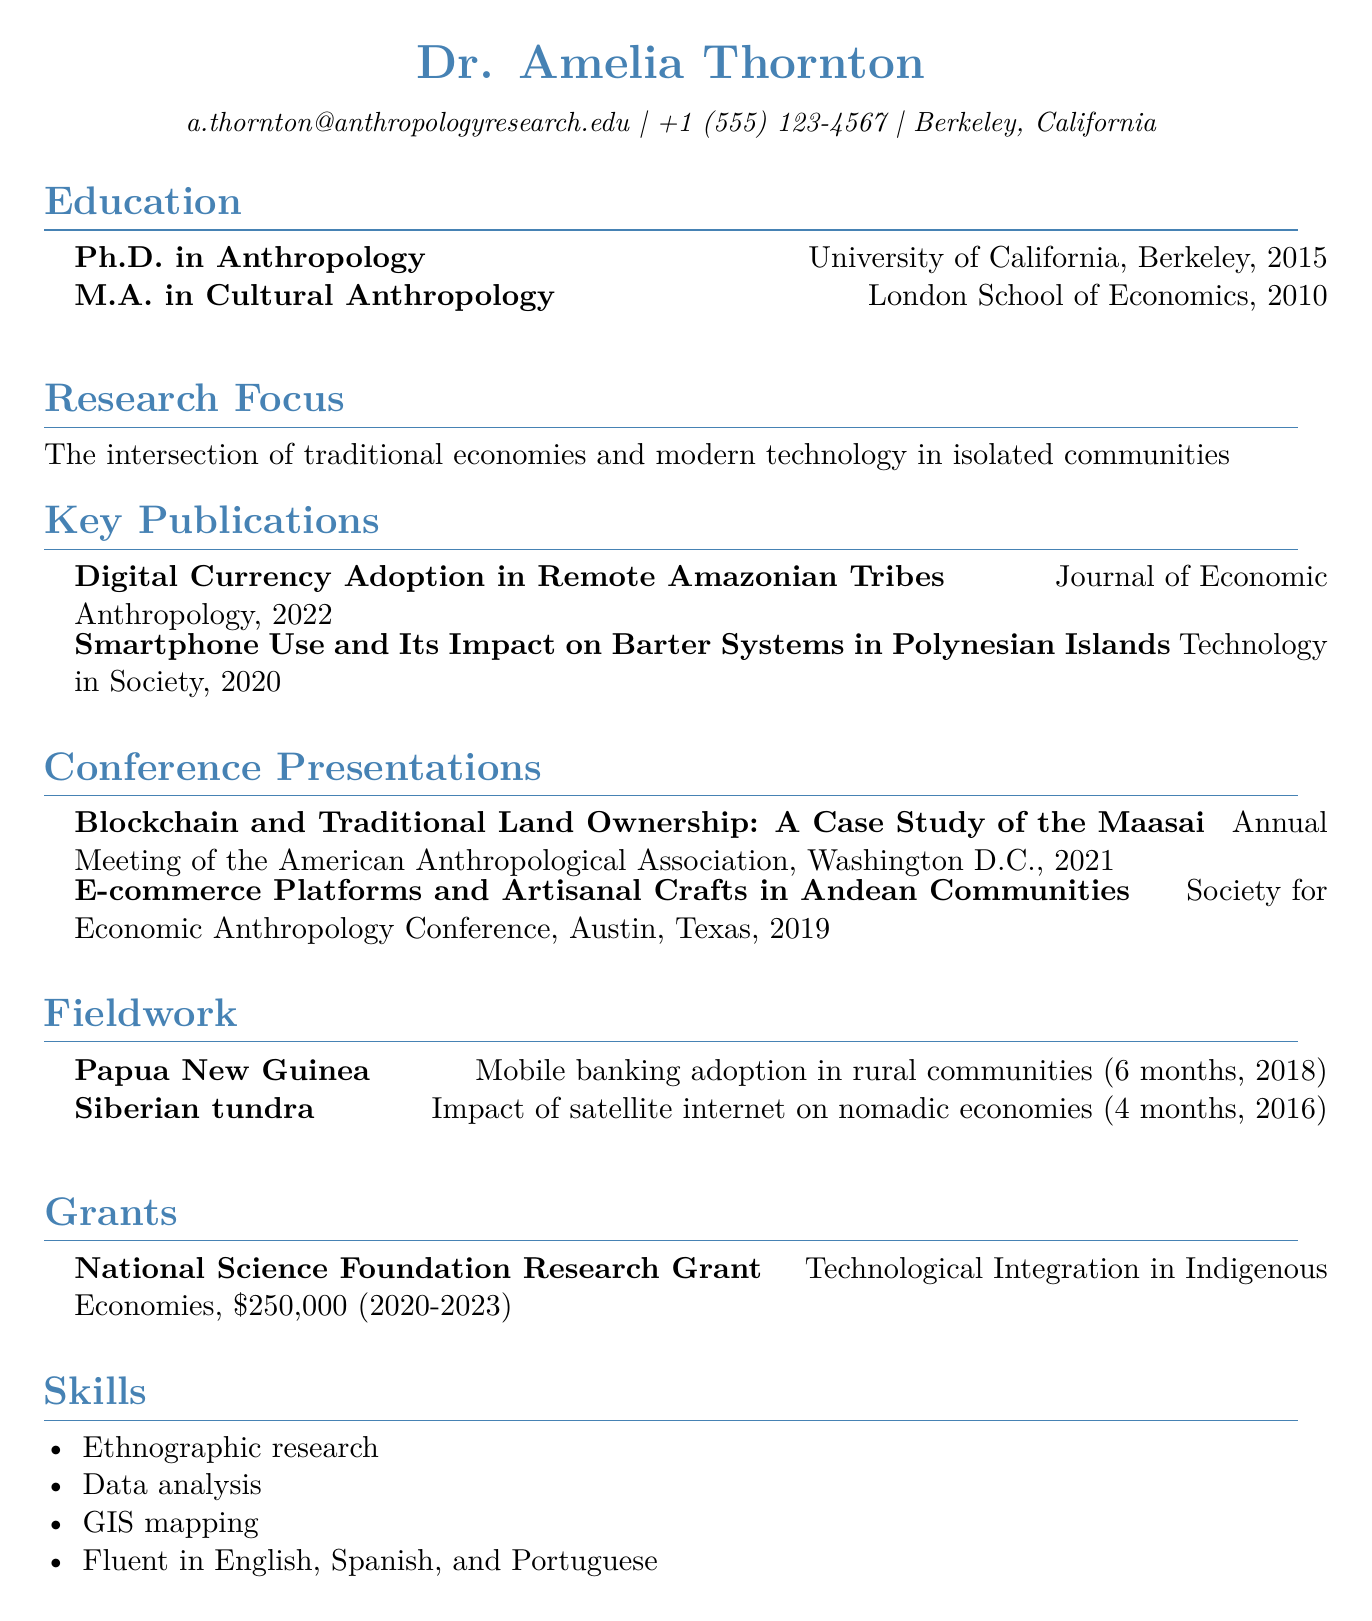What is the author's name? The author's name is prominently displayed at the top of the document under their credentials.
Answer: Dr. Amelia Thornton What year did the author complete their Ph.D.? The document specifies the year the author received their Ph.D. in Anthropology.
Answer: 2015 What is the focus of the author's research? The document outlines the author's main area of academic interest in the research focus section.
Answer: The intersection of traditional economies and modern technology in isolated communities How many conference presentations has the author made? By counting the entries listed, we can determine the number of presentations the author has delivered.
Answer: 2 What grant did the author receive, and what was its amount? The author has a section dedicated to grants, which includes the name and financial support of the grant received.
Answer: National Science Foundation Research Grant, $250,000 What skills does the author possess related to their research? The skills section lists various competencies which are pertinent to the author's fieldwork and research.
Answer: Ethnographic research, Data analysis, GIS mapping, Fluent in English, Spanish, and Portuguese What year was the publication "Digital Currency Adoption in Remote Amazonian Tribes" released? This information can be found under the key publications section along with the publication title.
Answer: 2022 In which location did the author conduct fieldwork on mobile banking adoption? The fieldwork section provides specific locations and focuses of the author's field studies.
Answer: Papua New Guinea 